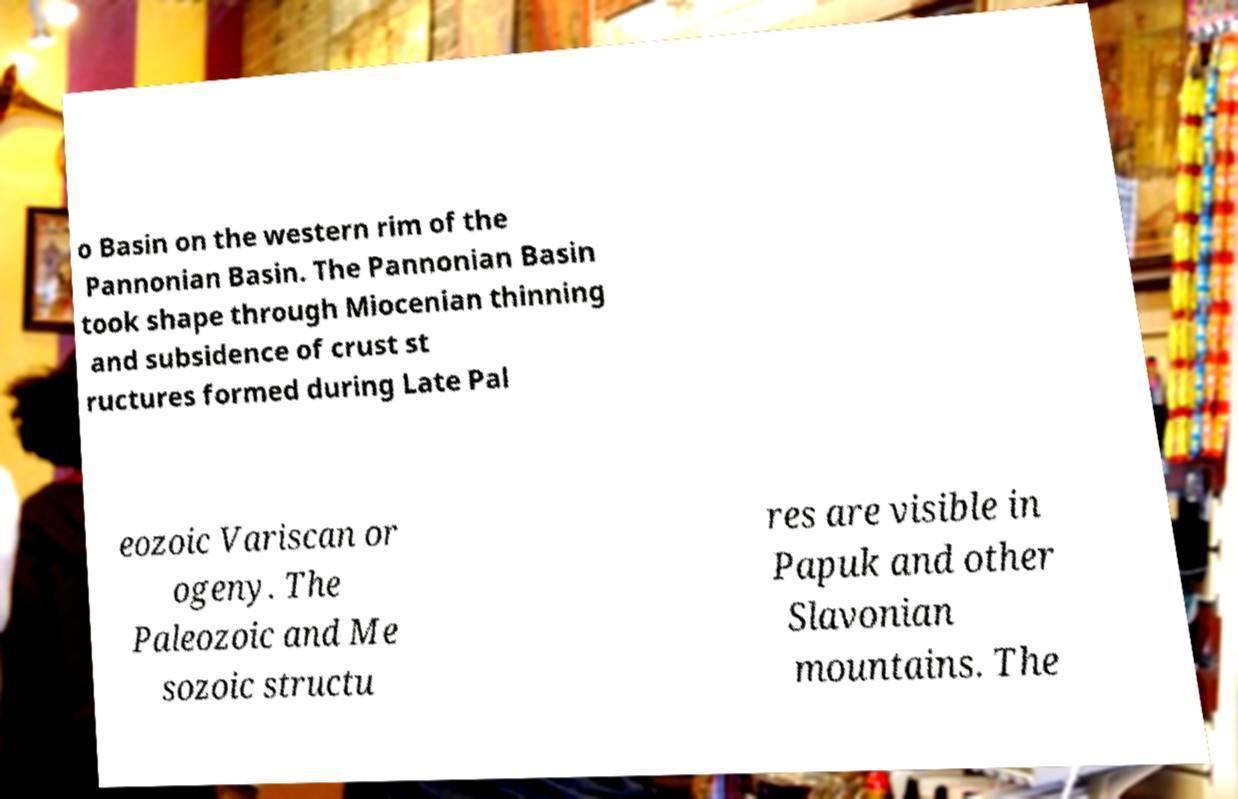Can you accurately transcribe the text from the provided image for me? o Basin on the western rim of the Pannonian Basin. The Pannonian Basin took shape through Miocenian thinning and subsidence of crust st ructures formed during Late Pal eozoic Variscan or ogeny. The Paleozoic and Me sozoic structu res are visible in Papuk and other Slavonian mountains. The 